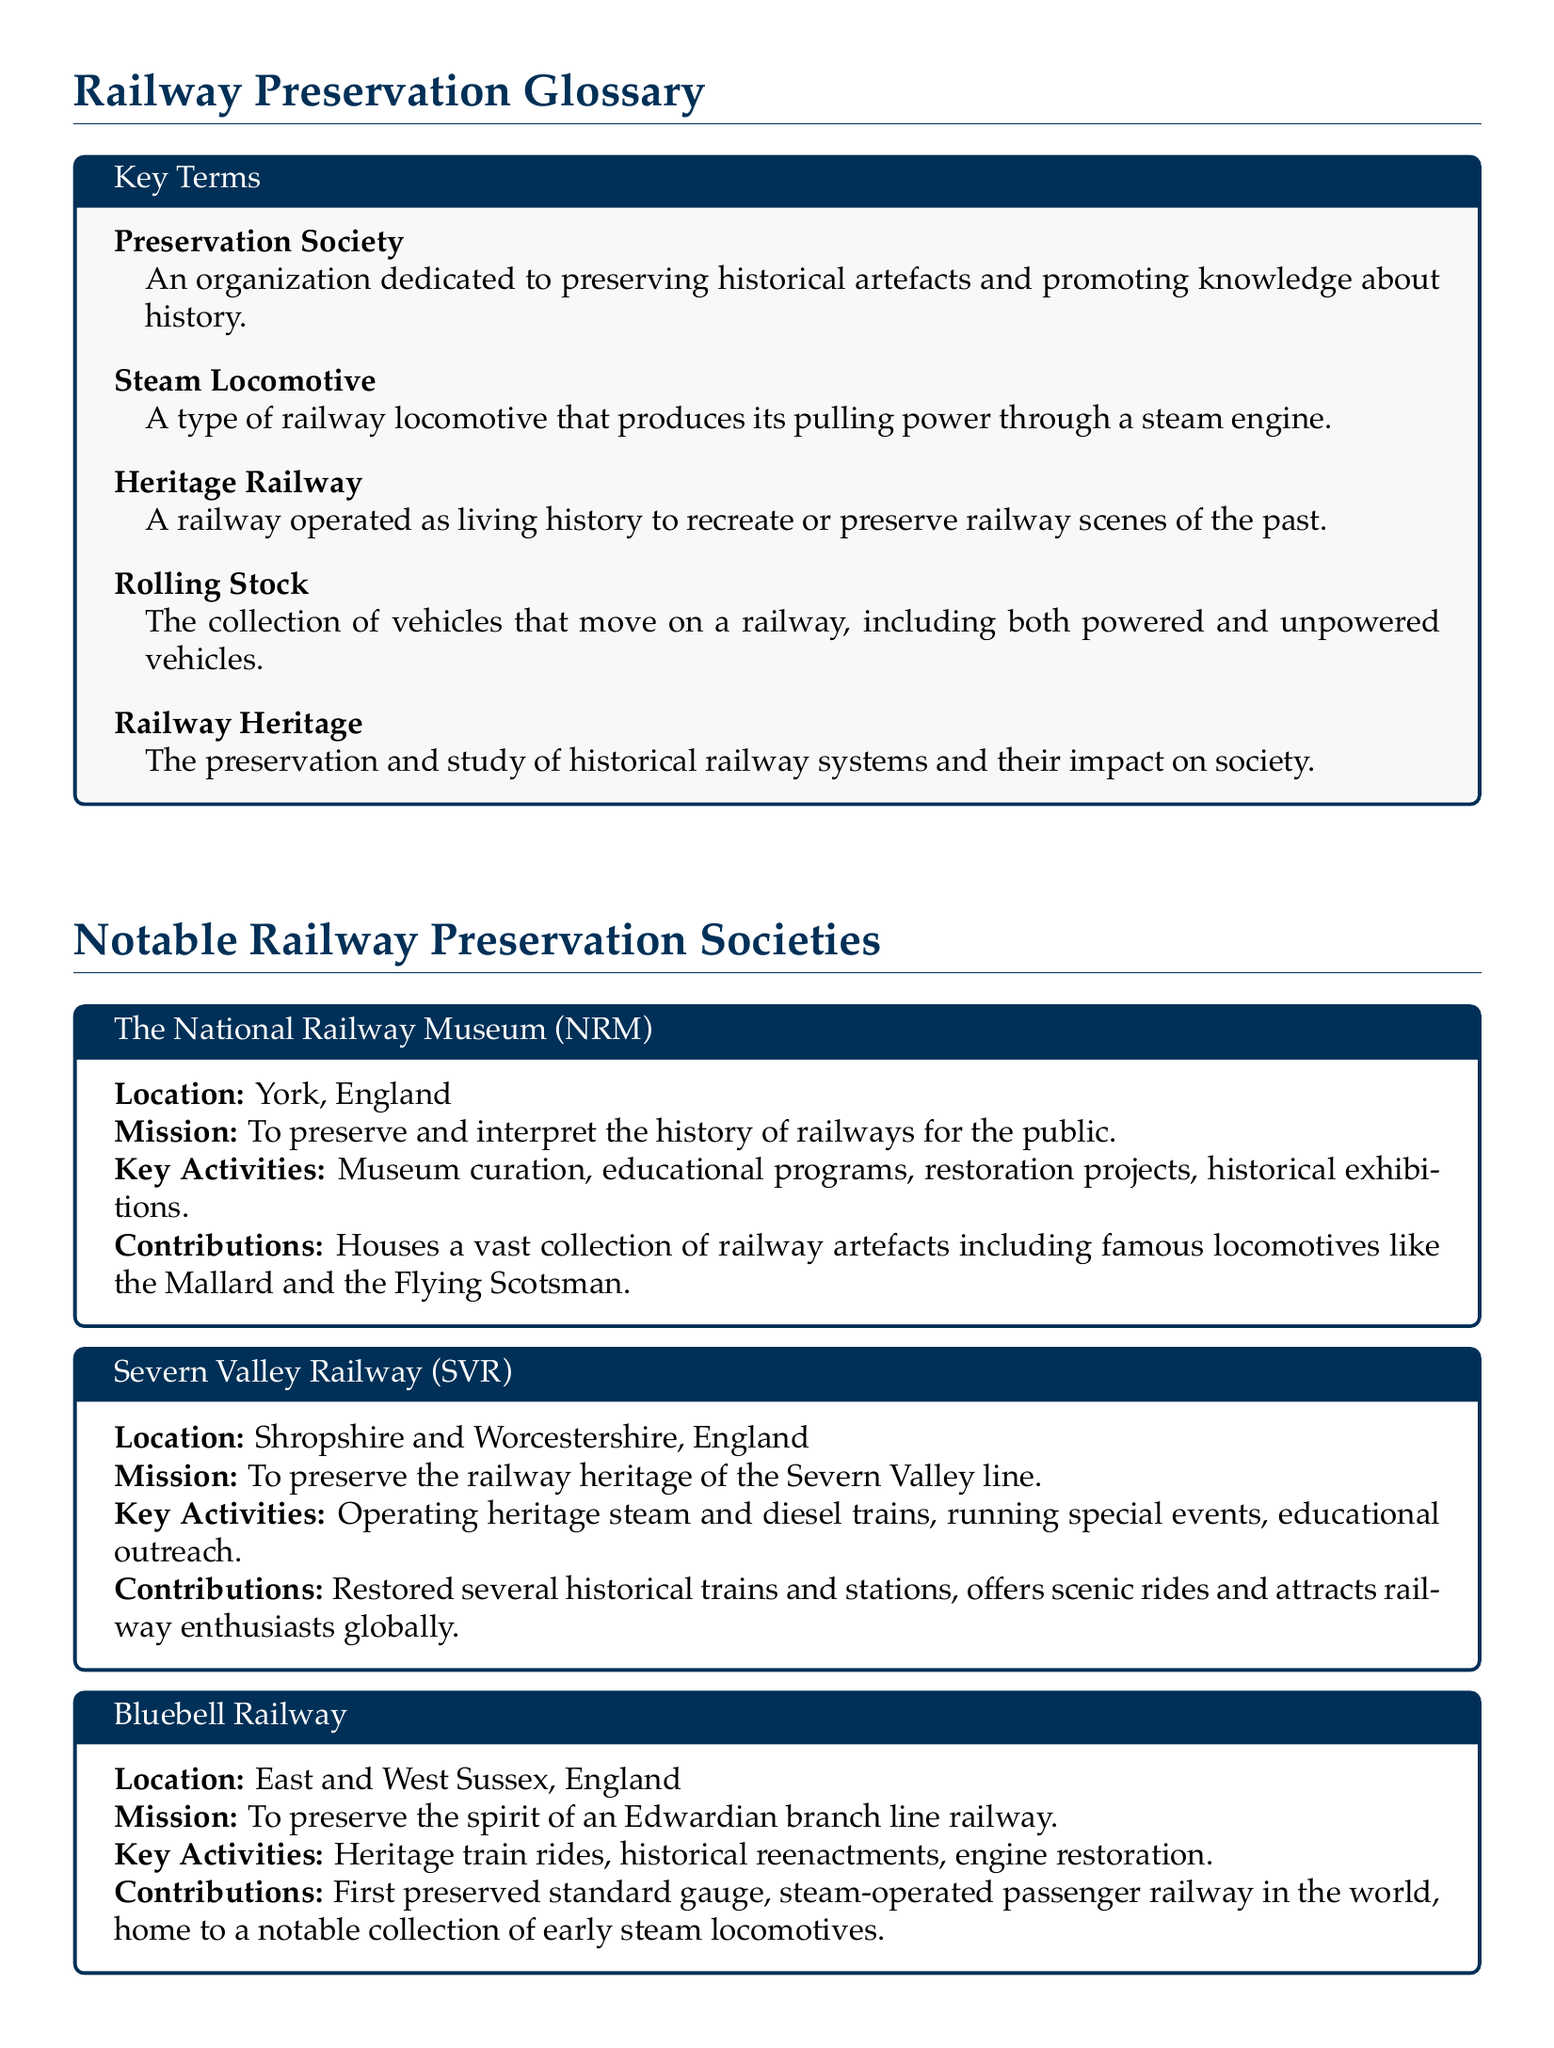What is a Preservation Society? A Preservation Society is defined as an organization dedicated to preserving historical artefacts and promoting knowledge about history.
Answer: An organization dedicated to preserving historical artefacts and promoting knowledge about history Where is the National Railway Museum located? The document states that the National Railway Museum is located in York, England.
Answer: York, England What is the mission of the Bluebell Railway? The mission of the Bluebell Railway is to preserve the spirit of an Edwardian branch line railway.
Answer: To preserve the spirit of an Edwardian branch line railway How many notable railway preservation societies are listed in the document? The document lists a total of four notable railway preservation societies.
Answer: Four What type of railway is the Ffestiniog & Welsh Highland Railways known for preserving? The Ffestiniog & Welsh Highland Railways is known for preserving narrow-gauge locomotives and rolling stock.
Answer: Narrow-gauge locomotives and rolling stock What key activity does the Severn Valley Railway engage in to attract railway enthusiasts? A key activity of the Severn Valley Railway is operating heritage steam and diesel trains.
Answer: Operating heritage steam and diesel trains What collections does the National Railway Museum house? The National Railway Museum houses a vast collection of railway artefacts including famous locomotives like the Mallard and the Flying Scotsman.
Answer: A vast collection of railway artefacts including famous locomotives like the Mallard and the Flying Scotsman What is the longest heritage railway in the UK? The document states that the longest heritage railway in the UK is the Ffestiniog & Welsh Highland Railways.
Answer: Ffestiniog & Welsh Highland Railways What type of reenactments does the Bluebell Railway conduct? The Bluebell Railway conducts historical reenactments as part of its key activities.
Answer: Historical reenactments 